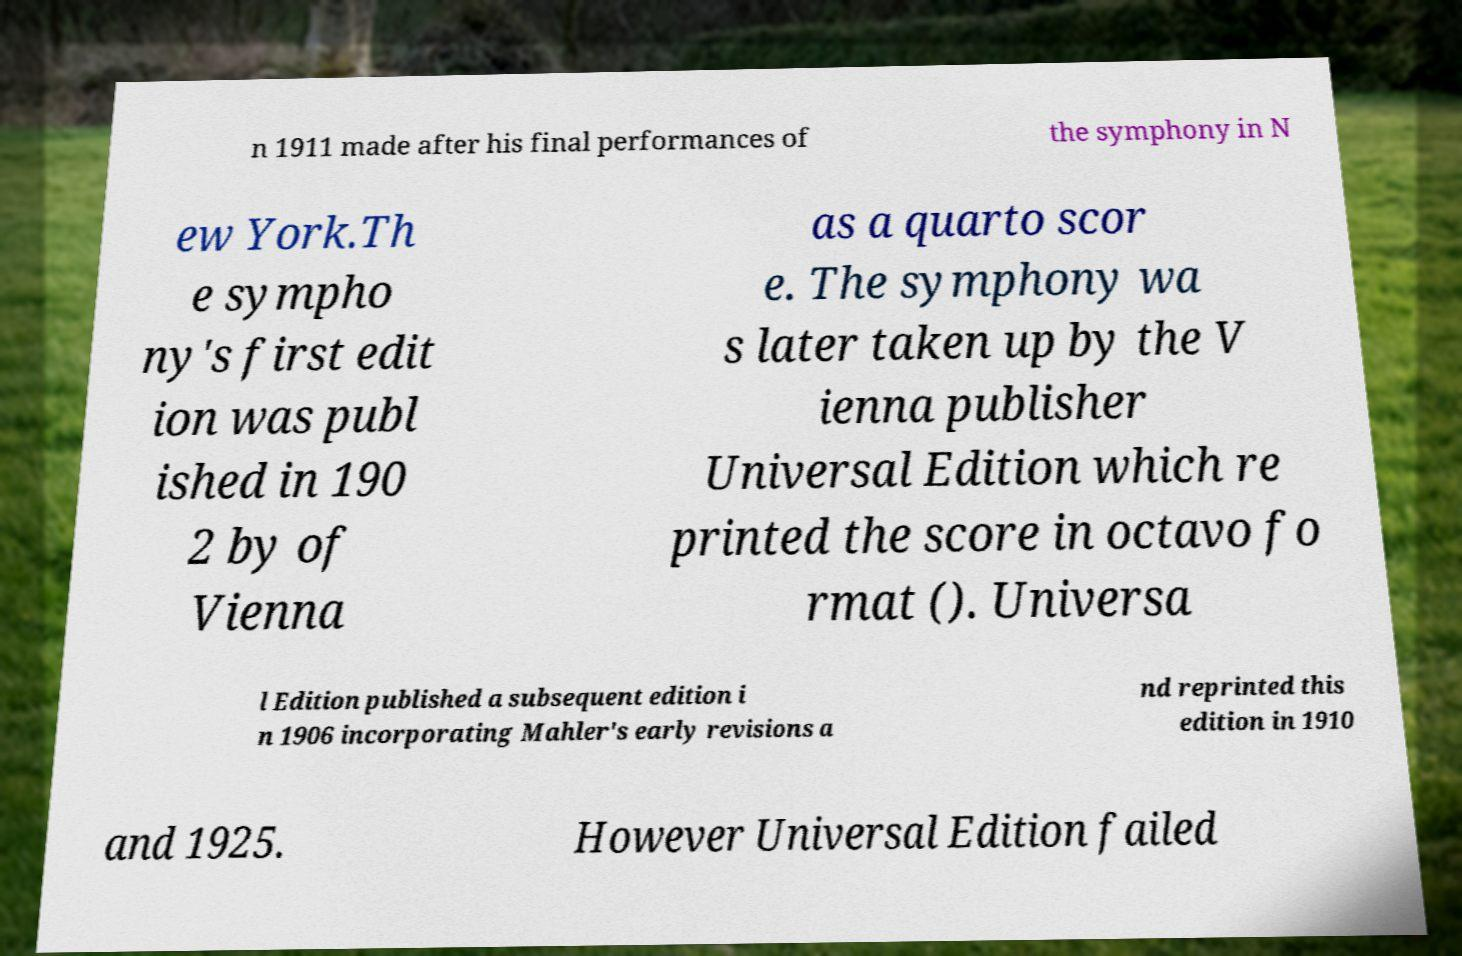What messages or text are displayed in this image? I need them in a readable, typed format. n 1911 made after his final performances of the symphony in N ew York.Th e sympho ny's first edit ion was publ ished in 190 2 by of Vienna as a quarto scor e. The symphony wa s later taken up by the V ienna publisher Universal Edition which re printed the score in octavo fo rmat (). Universa l Edition published a subsequent edition i n 1906 incorporating Mahler's early revisions a nd reprinted this edition in 1910 and 1925. However Universal Edition failed 